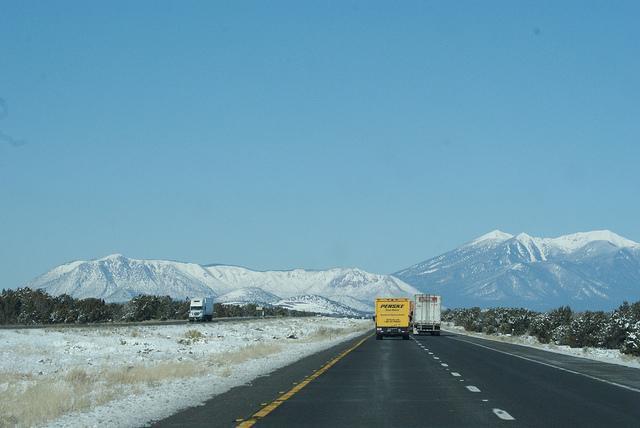How many trucks are coming towards the camera?
Give a very brief answer. 1. How many people are holding tennis rackets?
Give a very brief answer. 0. 